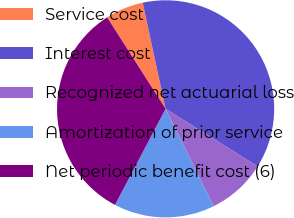Convert chart. <chart><loc_0><loc_0><loc_500><loc_500><pie_chart><fcel>Service cost<fcel>Interest cost<fcel>Recognized net actuarial loss<fcel>Amortization of prior service<fcel>Net periodic benefit cost (6)<nl><fcel>5.67%<fcel>37.28%<fcel>8.83%<fcel>14.99%<fcel>33.23%<nl></chart> 